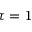<formula> <loc_0><loc_0><loc_500><loc_500>\tau = 1</formula> 